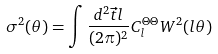<formula> <loc_0><loc_0><loc_500><loc_500>\sigma ^ { 2 } ( \theta ) = \int \frac { d ^ { 2 } \vec { t } { l } } { ( 2 \pi ) ^ { 2 } } C _ { l } ^ { \Theta \Theta } W ^ { 2 } ( l \theta )</formula> 